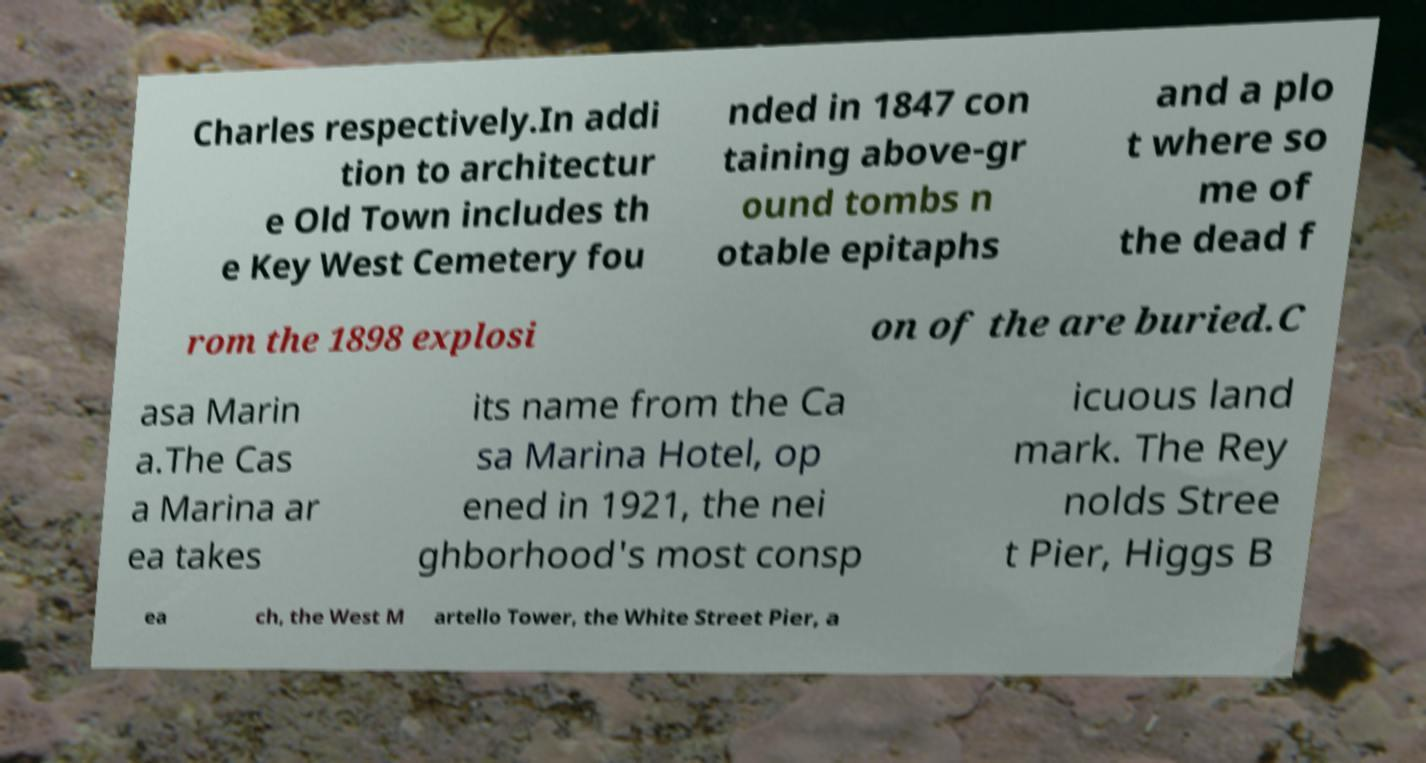Please read and relay the text visible in this image. What does it say? Charles respectively.In addi tion to architectur e Old Town includes th e Key West Cemetery fou nded in 1847 con taining above-gr ound tombs n otable epitaphs and a plo t where so me of the dead f rom the 1898 explosi on of the are buried.C asa Marin a.The Cas a Marina ar ea takes its name from the Ca sa Marina Hotel, op ened in 1921, the nei ghborhood's most consp icuous land mark. The Rey nolds Stree t Pier, Higgs B ea ch, the West M artello Tower, the White Street Pier, a 